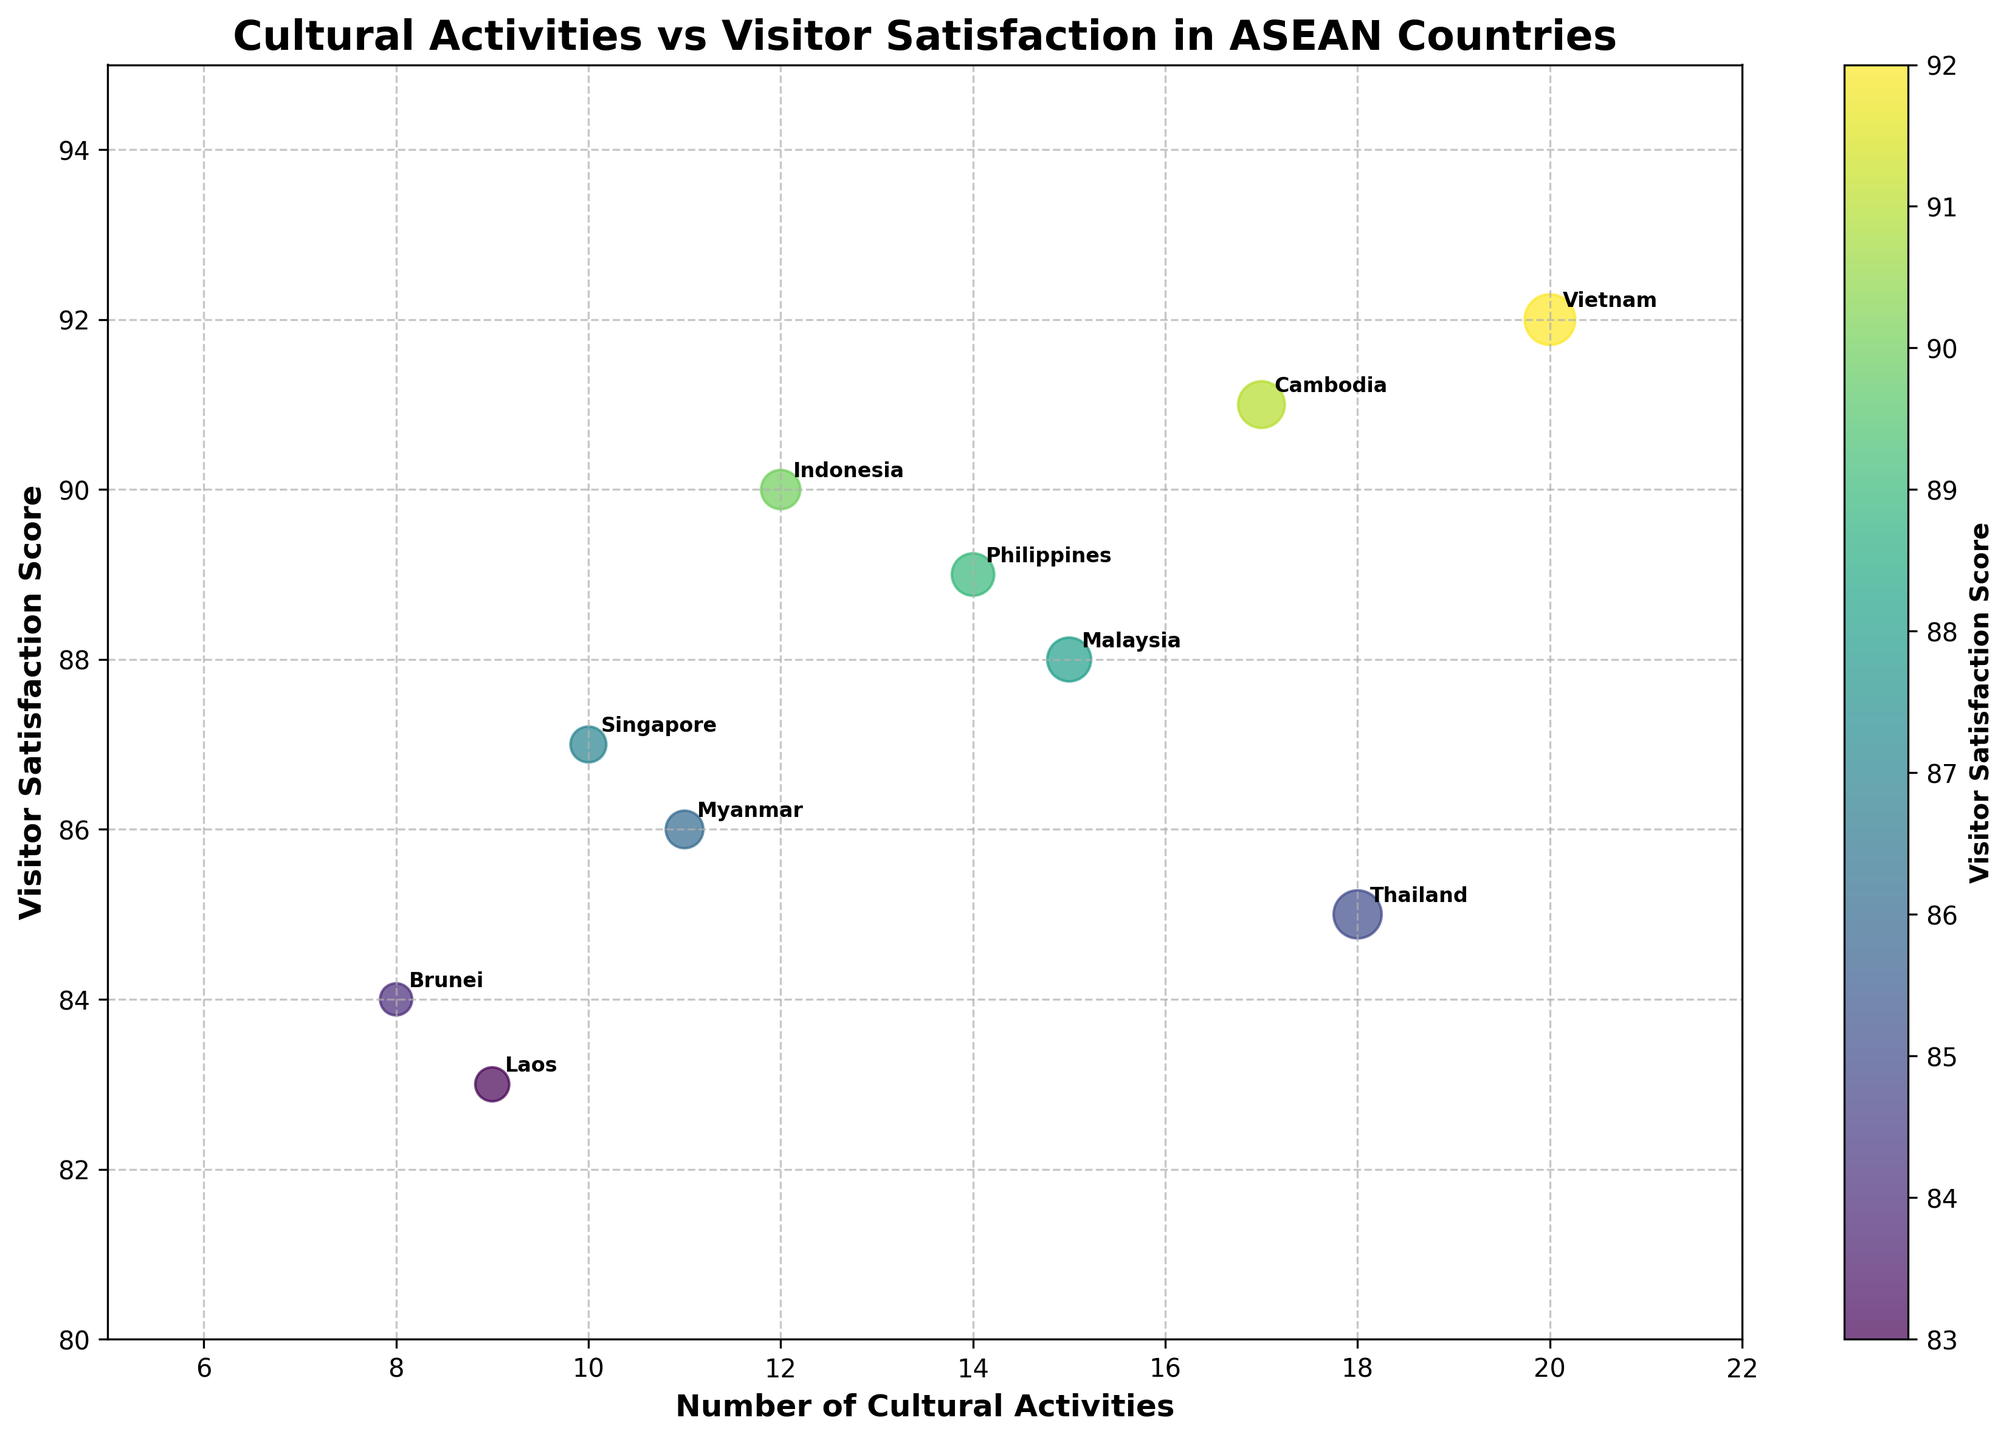What is the title of the figure? The title is often displayed prominently at the top of the figure, providing a summary of what the figure represents. In this case, we can refer to the top part of the figure.
Answer: Cultural Activities vs Visitor Satisfaction in ASEAN Countries How many countries are represented in the scatter plot? Count the number of distinct points or labels annotated on the plot. Each country is labeled next to its respective data point. From the figure, there are 10 countries represented.
Answer: 10 Which country has the highest visitor satisfaction score? Check the vertical axis representing 'Visitor Satisfaction Score' and find the highest data point. Annotate the corresponding country label. In this case, the highest score is for Vietnam (92).
Answer: Vietnam Which country organized the most number of cultural activities? Examine the horizontal axis for 'Number of Cultural Activities' and identify the farthest data point to the right. Annotate the corresponding country label. Here, Vietnam organized the most activities (20).
Answer: Vietnam What is the average visitor satisfaction score across all countries? Sum the visitor satisfaction scores of all countries and then divide by the number of countries. Scores: 88 + 85 + 90 + 92 + 89 + 87 + 84 + 83 + 86 + 91 = 875. Divide by 10 (number of countries) to get the average.
Answer: 87.5 What is the range of the number of cultural activities organized? Identify the minimum and maximum number of cultural activities from the x-axis values, then calculate the difference. Minimum is 8, and the maximum is 20, so the range is 20 - 8 = 12.
Answer: 12 Which two countries have the closest visitor satisfaction scores? Compare visitor satisfaction scores to find the smallest difference between any two countries. Myanmar (86) and Singapore (87) have the smallest difference of 1.
Answer: Myanmar and Singapore How does the visitor satisfaction score for Cambodia compare to that of Malaysia? Look at the y-axis values for Cambodia and Malaysia and compare their scores. Cambodia has a score of 91 while Malaysia has a score of 88, indicating Cambodia has a higher score.
Answer: Cambodia is higher What trend, if any, is visible between the number of cultural activities and visitor satisfaction scores? By visually examining the scatter plot, identify any apparent relationship or pattern between the number of cultural activities (x-axis) and visitor satisfaction scores (y-axis). There is a slight positive trend where more activities correlate with higher satisfaction scores.
Answer: Positive correlation Which country is represented by the data point closest to the bottom left of the plot? The bottom left data point has the smallest x and y values. Check the labels for the lowest number of activities and satisfaction scores. Brunei, with 8 activities and a satisfaction score of 84, is the closest.
Answer: Brunei 